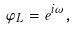<formula> <loc_0><loc_0><loc_500><loc_500>\varphi _ { L } = e ^ { i \omega } ,</formula> 